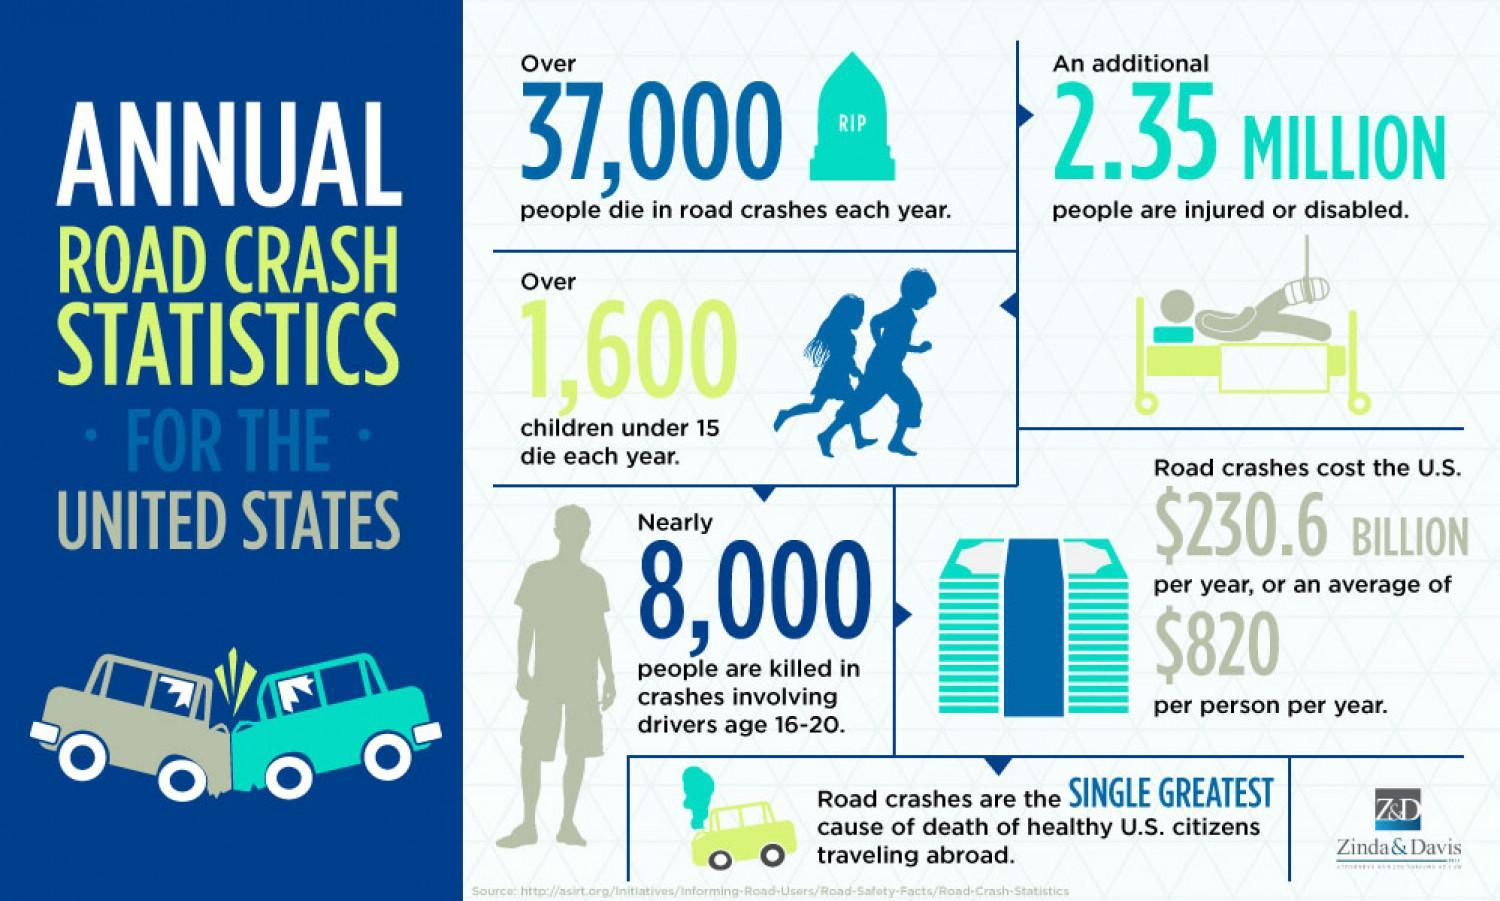What is an average road crash cost the U.S. per person per year?
Answer the question with a short phrase. $820 What is the no of injured or disabled people in road crashes each year in the U.S.? 2.35 Million Which age group of drivers are mainly killed in the annual road crashes? 16-20 What is the major cause of death that contributes to the healthy U.S. citizens traveling abroad? Road crashes What is the no of children under 15 years died each year by a road crash in U.S? Over 1,600 What is the total no of people died in a road crash each year in the U.S? Over 37,000 